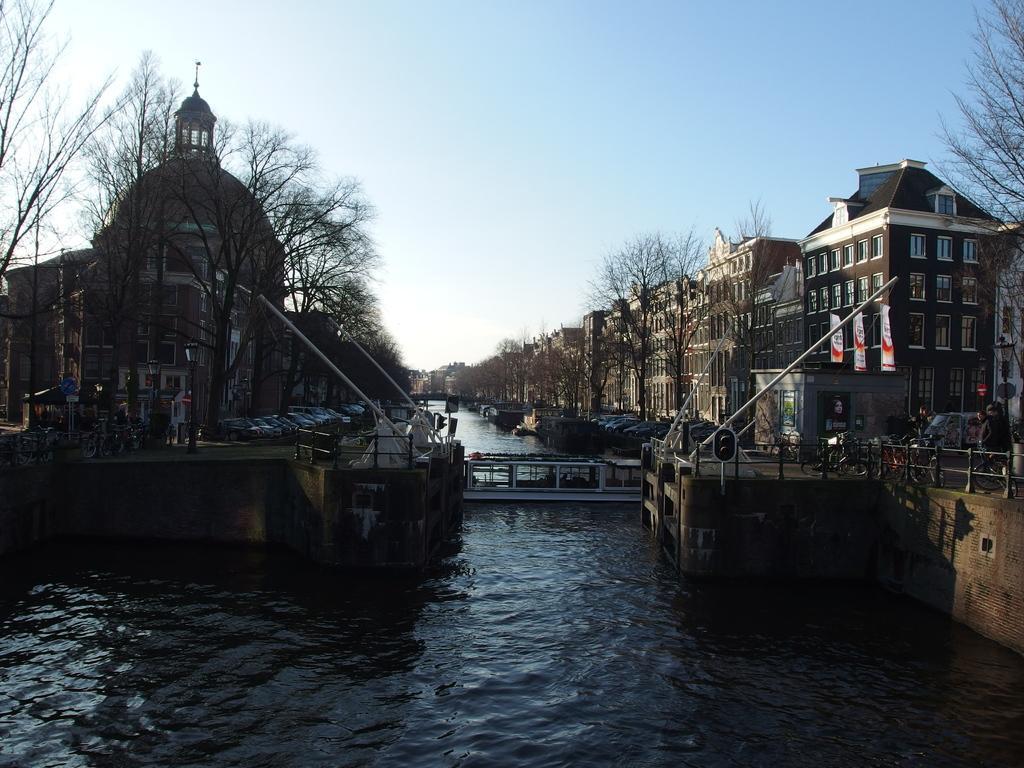How would you summarize this image in a sentence or two? In the image there is a river, across the river there is a bridge and on the either side of the river there are vehicles, buildings and trees. 